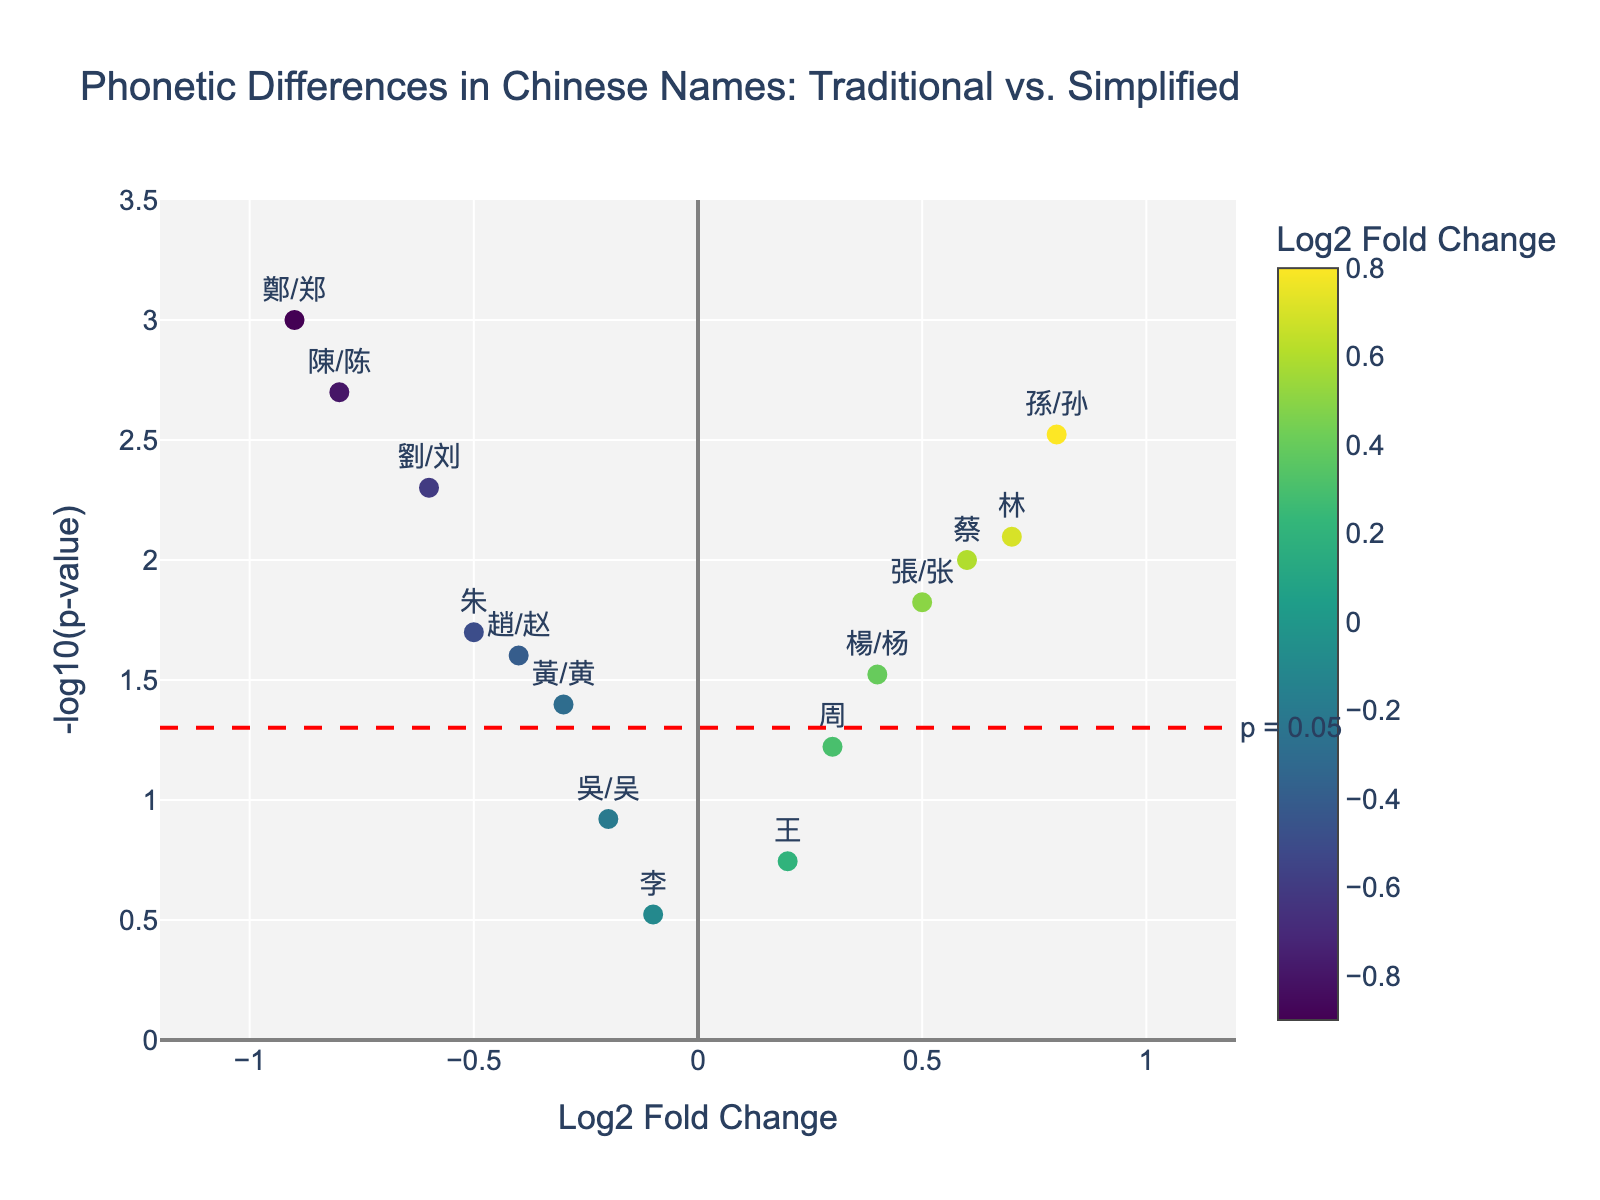what is the title of the plot? The title is located at the top center of the figure, and it should summarize the main idea of the plot.
Answer: Phonetic Differences in Chinese Names: Traditional vs. Simplified how many characters are analyzed in the figure? Each marker represents a character on the scatter plot. Count the markers or refer to the hover text to get the total number.
Answer: 15 which character has the highest Log2 Fold Change? Identify the data point with the highest x-value, which represents the Log2 Fold Change.
Answer: 孫/孙 which character is the most statistically significant? The p-value represents statistical significance, so the highest -log10(p-value) will indicate the most significant character.
Answer: 鄭/郑 what is the Log2 Fold Change for 林? Find the marker for 林 on the x-axis and note its x-coordinate.
Answer: 0.7 how many characters have a p-value less than 0.05? Identify markers above the red horizontal line, which represents p = 0.05. Count these markers.
Answer: 10 which character has a Log2 Fold Change closest to zero? Find the marker that is closest to the vertical line at Log2 Fold Change = 0.
Answer: 李 compare the significance of 張/张 and 周. which one is more significant? Compare the y-values (-log10(p-value)) of 張/张 and 周. The higher value indicates more significance.
Answer: 張/张 what's the range of -log10(p-value) in this plot? Look at the y-axis to find the range from the minimum to the maximum value.
Answer: 0 to 3.5 are there more characters with negative or positive Log2 Fold Change? Compare the number of markers to the left (negative) and the right (positive) of the vertical line at Log2 Fold Change = 0.
Answer: More positive 